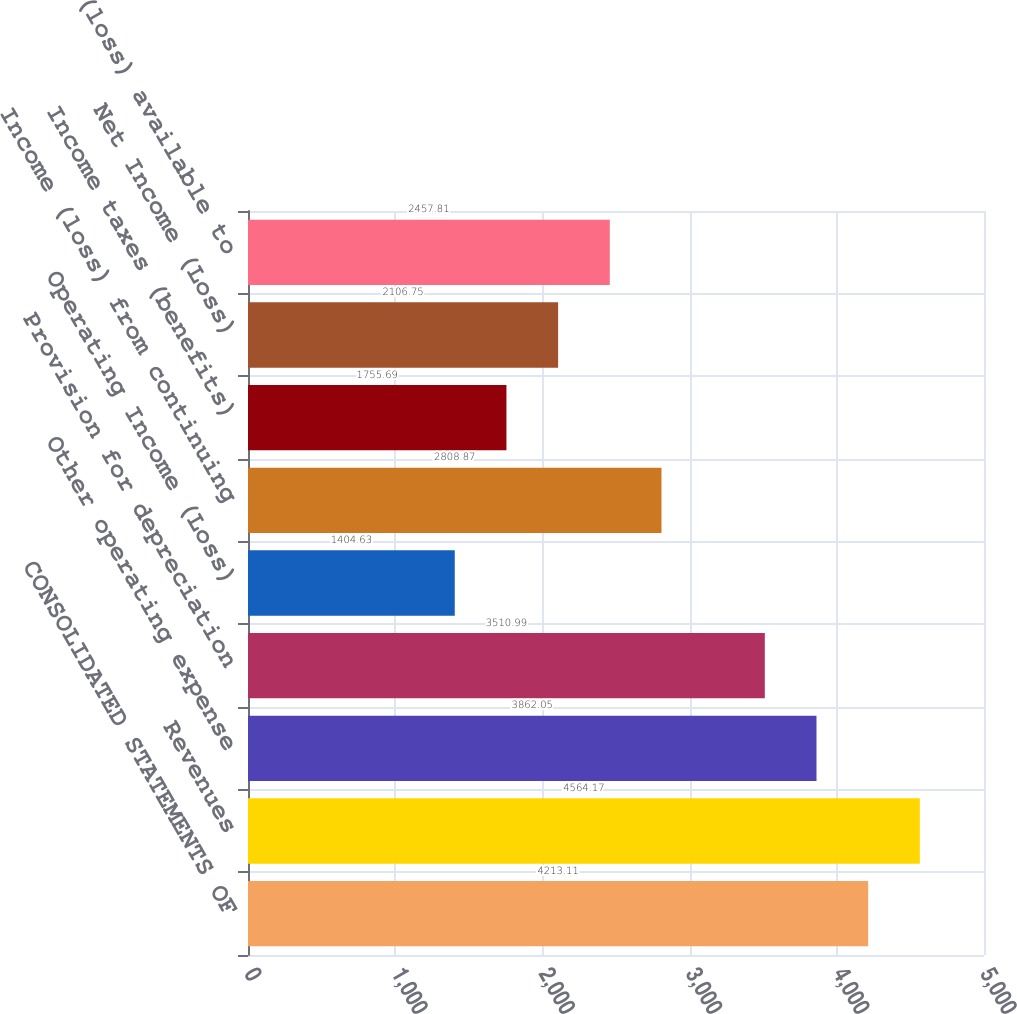Convert chart. <chart><loc_0><loc_0><loc_500><loc_500><bar_chart><fcel>CONSOLIDATED STATEMENTS OF<fcel>Revenues<fcel>Other operating expense<fcel>Provision for depreciation<fcel>Operating Income (Loss)<fcel>Income (loss) from continuing<fcel>Income taxes (benefits)<fcel>Net Income (Loss)<fcel>Earnings (loss) available to<nl><fcel>4213.11<fcel>4564.17<fcel>3862.05<fcel>3510.99<fcel>1404.63<fcel>2808.87<fcel>1755.69<fcel>2106.75<fcel>2457.81<nl></chart> 